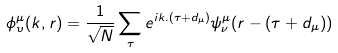<formula> <loc_0><loc_0><loc_500><loc_500>\phi _ { \upsilon } ^ { \mu } ( k , r ) = \frac { 1 } { \sqrt { N } } \sum _ { \tau } e ^ { i k . ( \tau + d _ { \mu } ) } \psi _ { \nu } ^ { \mu } ( r - ( \tau + d _ { \mu } ) )</formula> 